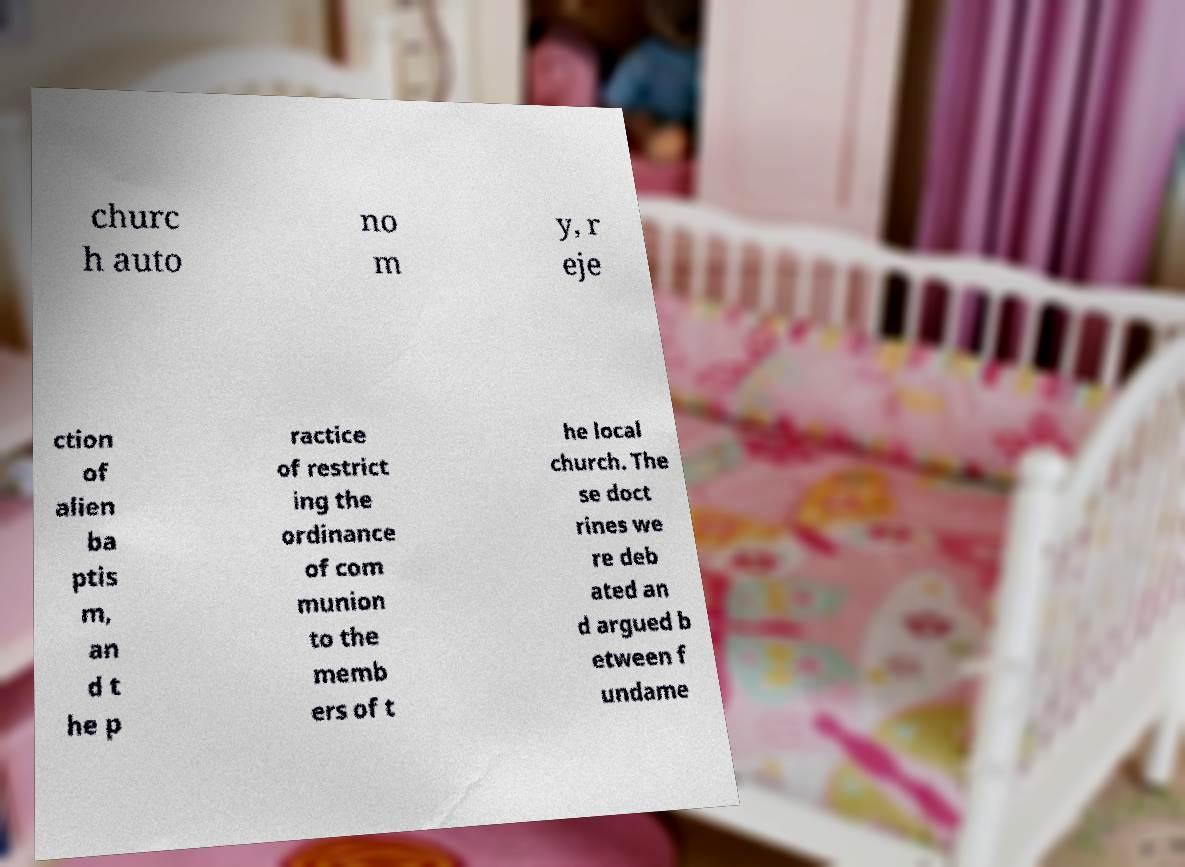There's text embedded in this image that I need extracted. Can you transcribe it verbatim? churc h auto no m y, r eje ction of alien ba ptis m, an d t he p ractice of restrict ing the ordinance of com munion to the memb ers of t he local church. The se doct rines we re deb ated an d argued b etween f undame 